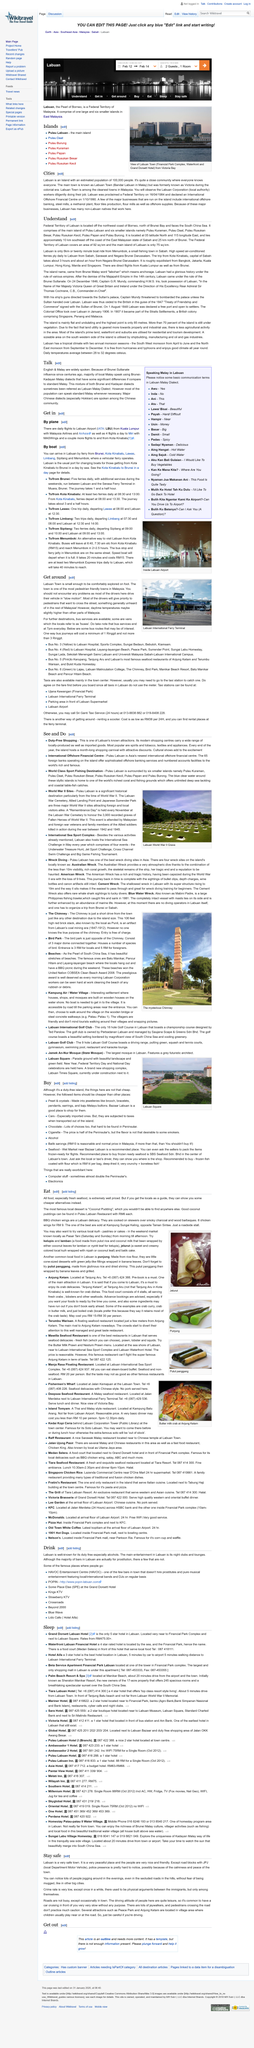Highlight a few significant elements in this photo. The bus services conclude their operations every day at 7:00 pm. Labuan, located in the South China Sea, is faced by the vast expanse of the Pacific Ocean. The federal territory of Labuan is the main focus of the article. Labuan Town is widely recognized as the most pedestrian-friendly town in Malaysia. Terminal Feri Antarabangsa Labuan is the name of the building in the picture. 